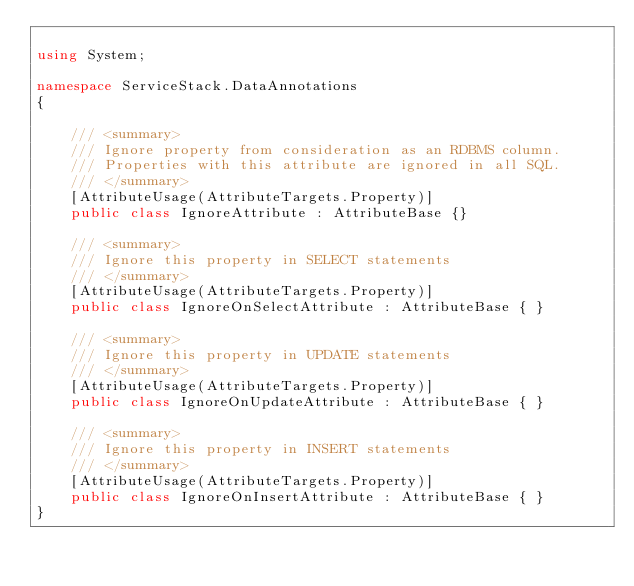Convert code to text. <code><loc_0><loc_0><loc_500><loc_500><_C#_>
using System;

namespace ServiceStack.DataAnnotations
{

    /// <summary>
    /// Ignore property from consideration as an RDBMS column.
    /// Properties with this attribute are ignored in all SQL.
    /// </summary>
    [AttributeUsage(AttributeTargets.Property)]
    public class IgnoreAttribute : AttributeBase {}

    /// <summary>
    /// Ignore this property in SELECT statements
    /// </summary>
    [AttributeUsage(AttributeTargets.Property)]
    public class IgnoreOnSelectAttribute : AttributeBase { }

    /// <summary>
    /// Ignore this property in UPDATE statements
    /// </summary>
    [AttributeUsage(AttributeTargets.Property)]
    public class IgnoreOnUpdateAttribute : AttributeBase { }

    /// <summary>
    /// Ignore this property in INSERT statements
    /// </summary>
    [AttributeUsage(AttributeTargets.Property)]
    public class IgnoreOnInsertAttribute : AttributeBase { }
}</code> 